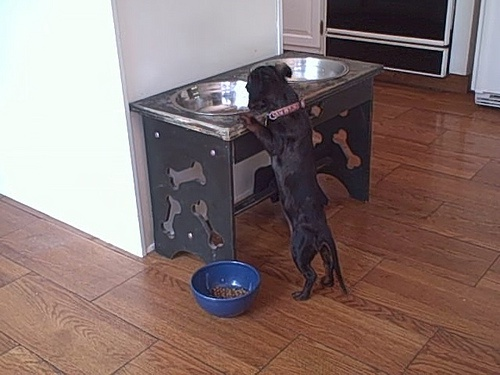Describe the objects in this image and their specific colors. I can see dog in lightblue, black, maroon, and gray tones, oven in lightblue, black, darkgray, gray, and lightgray tones, bowl in lightblue, navy, darkblue, purple, and black tones, refrigerator in lightblue, darkgray, and lightgray tones, and sink in lightblue, gray, white, and darkgray tones in this image. 